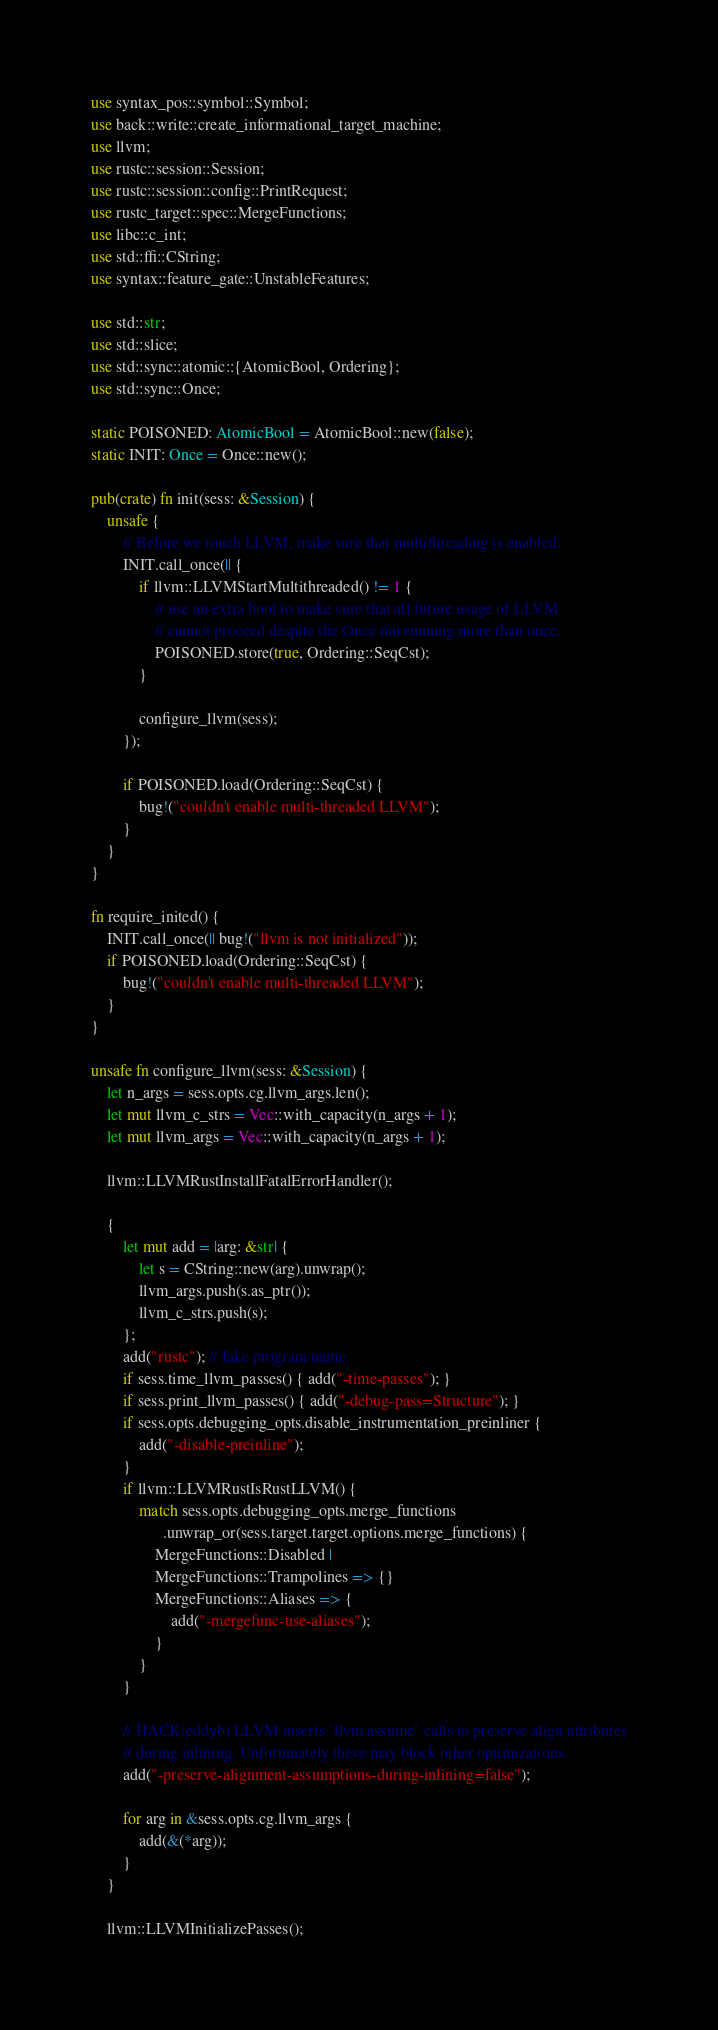<code> <loc_0><loc_0><loc_500><loc_500><_Rust_>use syntax_pos::symbol::Symbol;
use back::write::create_informational_target_machine;
use llvm;
use rustc::session::Session;
use rustc::session::config::PrintRequest;
use rustc_target::spec::MergeFunctions;
use libc::c_int;
use std::ffi::CString;
use syntax::feature_gate::UnstableFeatures;

use std::str;
use std::slice;
use std::sync::atomic::{AtomicBool, Ordering};
use std::sync::Once;

static POISONED: AtomicBool = AtomicBool::new(false);
static INIT: Once = Once::new();

pub(crate) fn init(sess: &Session) {
    unsafe {
        // Before we touch LLVM, make sure that multithreading is enabled.
        INIT.call_once(|| {
            if llvm::LLVMStartMultithreaded() != 1 {
                // use an extra bool to make sure that all future usage of LLVM
                // cannot proceed despite the Once not running more than once.
                POISONED.store(true, Ordering::SeqCst);
            }

            configure_llvm(sess);
        });

        if POISONED.load(Ordering::SeqCst) {
            bug!("couldn't enable multi-threaded LLVM");
        }
    }
}

fn require_inited() {
    INIT.call_once(|| bug!("llvm is not initialized"));
    if POISONED.load(Ordering::SeqCst) {
        bug!("couldn't enable multi-threaded LLVM");
    }
}

unsafe fn configure_llvm(sess: &Session) {
    let n_args = sess.opts.cg.llvm_args.len();
    let mut llvm_c_strs = Vec::with_capacity(n_args + 1);
    let mut llvm_args = Vec::with_capacity(n_args + 1);

    llvm::LLVMRustInstallFatalErrorHandler();

    {
        let mut add = |arg: &str| {
            let s = CString::new(arg).unwrap();
            llvm_args.push(s.as_ptr());
            llvm_c_strs.push(s);
        };
        add("rustc"); // fake program name
        if sess.time_llvm_passes() { add("-time-passes"); }
        if sess.print_llvm_passes() { add("-debug-pass=Structure"); }
        if sess.opts.debugging_opts.disable_instrumentation_preinliner {
            add("-disable-preinline");
        }
        if llvm::LLVMRustIsRustLLVM() {
            match sess.opts.debugging_opts.merge_functions
                  .unwrap_or(sess.target.target.options.merge_functions) {
                MergeFunctions::Disabled |
                MergeFunctions::Trampolines => {}
                MergeFunctions::Aliases => {
                    add("-mergefunc-use-aliases");
                }
            }
        }

        // HACK(eddyb) LLVM inserts `llvm.assume` calls to preserve align attributes
        // during inlining. Unfortunately these may block other optimizations.
        add("-preserve-alignment-assumptions-during-inlining=false");

        for arg in &sess.opts.cg.llvm_args {
            add(&(*arg));
        }
    }

    llvm::LLVMInitializePasses();
</code> 